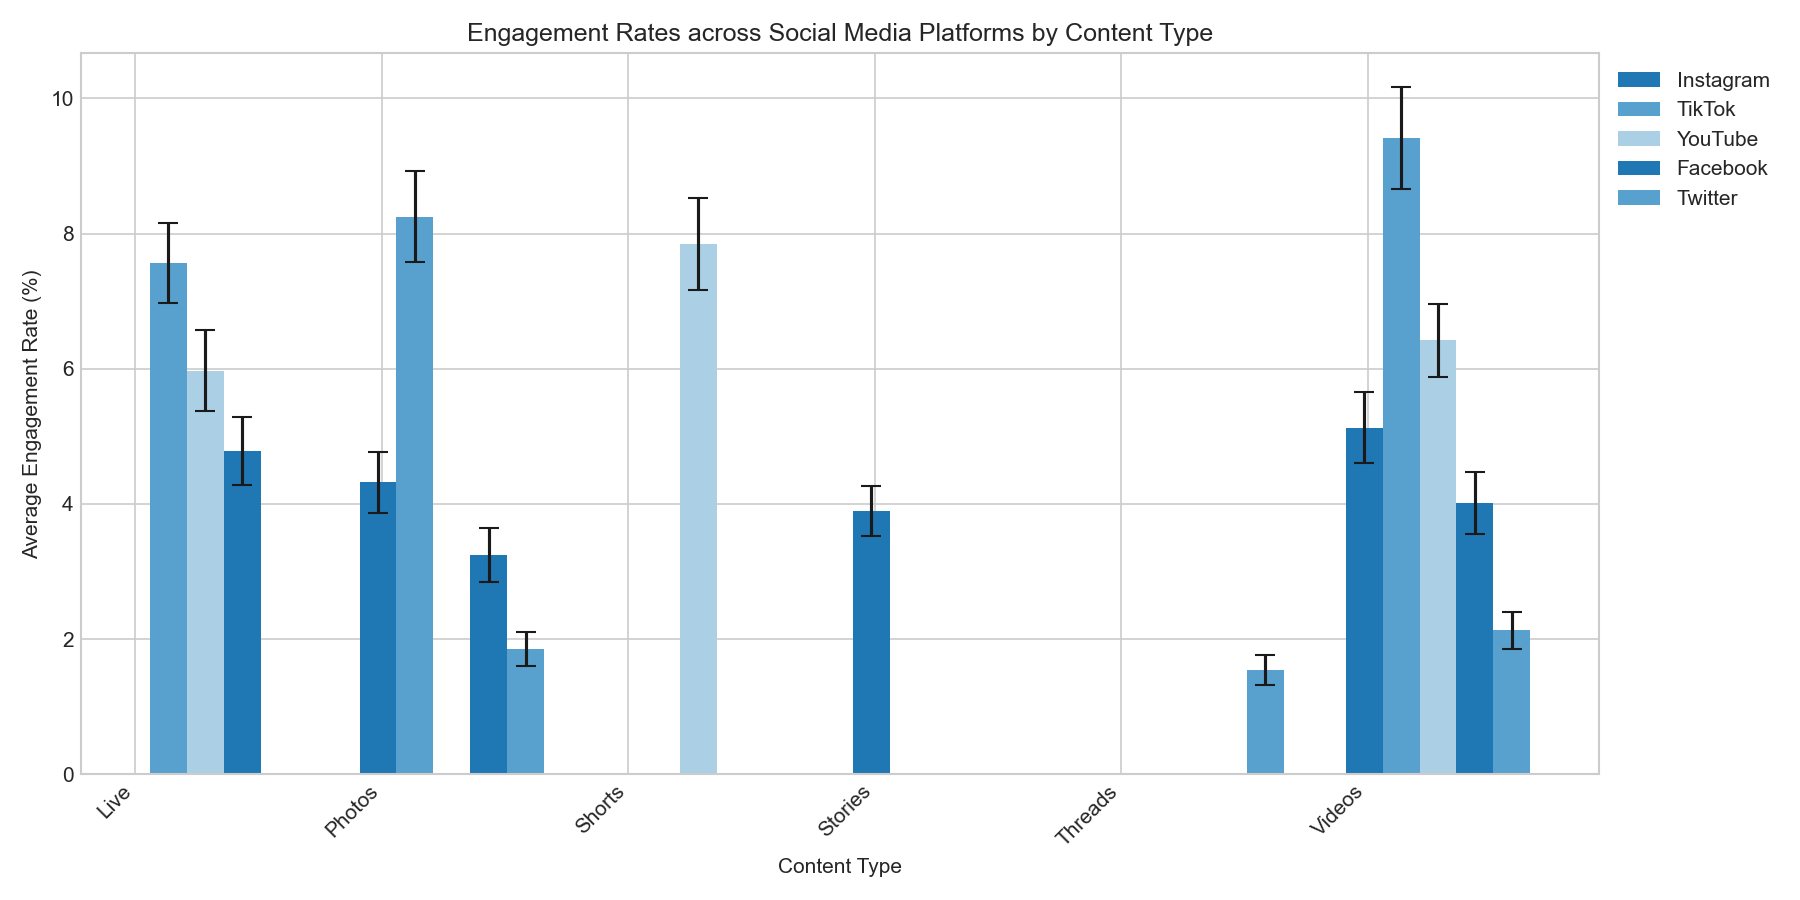What platform has the highest average engagement rate for videos? Refer to the bar heights for the "Videos" content type and see which platform's bar is the tallest. TikTok shows the highest average engagement rate with 9.41%.
Answer: TikTok Which content type has the smallest standard deviation in engagement rate for Instagram? Look at the error bars (y-error bars) for Instagram and find the content type with the smallest error bar. "Stories" has the smallest error bar among the Instagram content types.
Answer: Stories Compare the average engagement rates of YouTube Shorts and Facebook Live. Which is higher and by how much? Find the bar heights for "Shorts" under YouTube and "Live" under Facebook. For Shorts in YouTube, the average rate is 7.85%. For Live in Facebook, it's 4.78%. The difference is 7.85% - 4.78%.
Answer: YouTube Shorts is higher by 3.07% What is the average (mean) engagement rate for TikTok content types as shown in the chart? Sum the average engagement rates for TikTok (Photos, Videos, Live) and divide by 3. The rates are 8.25, 9.41, 7.56. \((8.25 + 9.41 + 7.56) / 3 = 8.407\).
Answer: 8.41% Which content type and platform combination has the lowest average engagement rate? Look at the shortest bar across the entire chart. Twitter Threads have the lowest average engagement rate of 1.54%.
Answer: Twitter Threads If you sum the average engagement rates for all Facebook content types, what result do you get? Add the engagement rates for Facebook Photos (3.25%), Videos (4.01%), and Live (4.78%). So, \((3.25 + 4.01 + 4.78) = 12.04\).
Answer: 12.04% How do the engagement rates for Instagram Photos and TikTok Photos compare in terms of absolute difference? Find the bars for Instagram Photos (4.32%) and TikTok Photos (8.25%) and calculate the absolute difference. \((8.25 - 4.32) = 3.93\).
Answer: 3.93% What is the engagement rate for the content type with the highest standard deviation across platforms? Examine the error bars and identify the largest. TikTok Videos' standard deviation of 0.75 is the highest. The average engagement rate for TikTok Videos is 9.41%.
Answer: 9.41% 